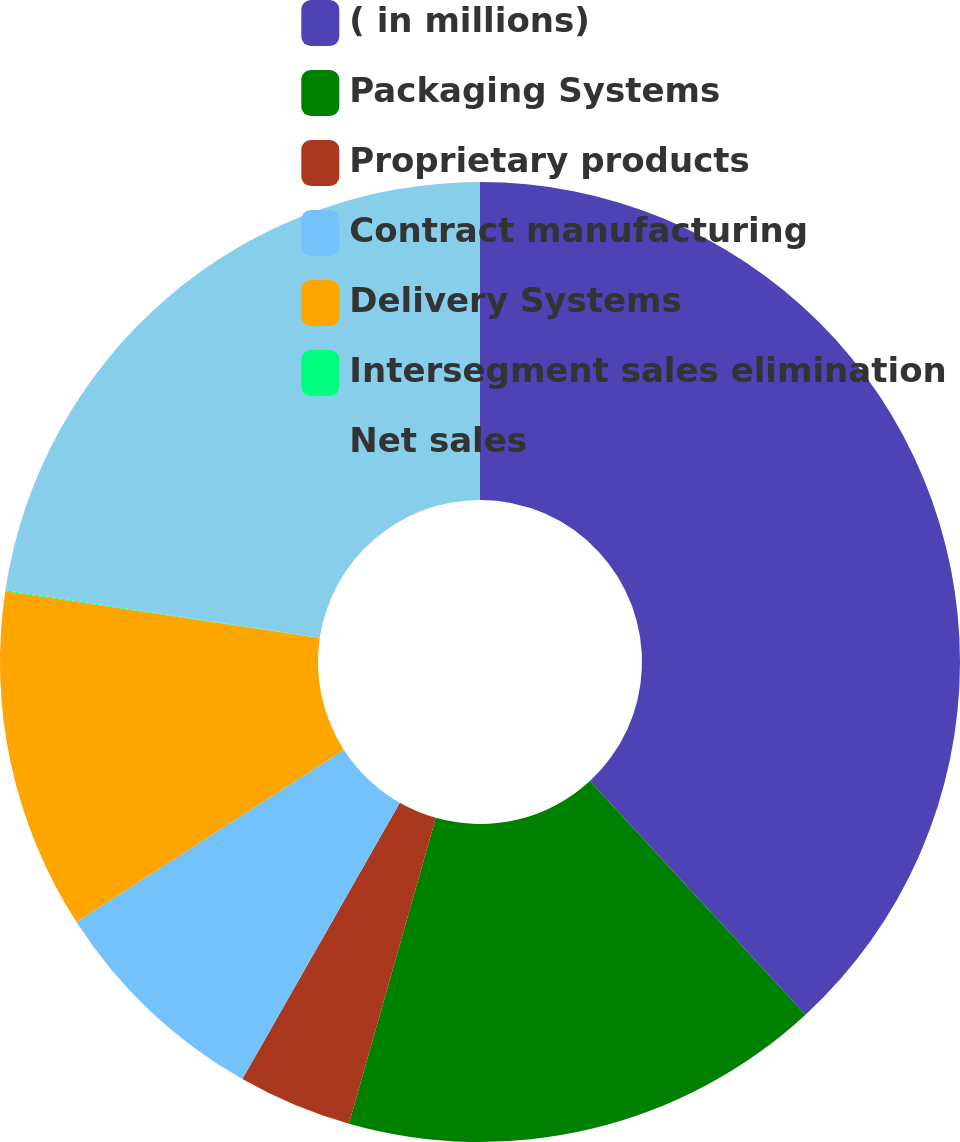Convert chart. <chart><loc_0><loc_0><loc_500><loc_500><pie_chart><fcel>( in millions)<fcel>Packaging Systems<fcel>Proprietary products<fcel>Contract manufacturing<fcel>Delivery Systems<fcel>Intersegment sales elimination<fcel>Net sales<nl><fcel>38.13%<fcel>16.26%<fcel>3.84%<fcel>7.65%<fcel>11.46%<fcel>0.03%<fcel>22.61%<nl></chart> 